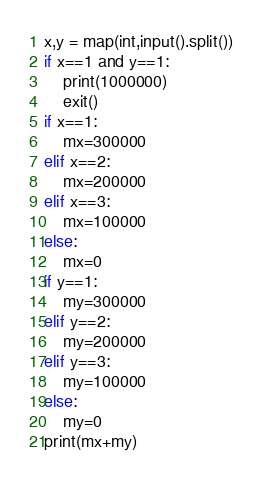<code> <loc_0><loc_0><loc_500><loc_500><_Python_>x,y = map(int,input().split())
if x==1 and y==1:
    print(1000000)
    exit()
if x==1:
    mx=300000
elif x==2:    
    mx=200000
elif x==3:    
    mx=100000    
else:
    mx=0
if y==1:
    my=300000
elif y==2:    
    my=200000
elif y==3:    
    my=100000    
else:
    my=0
print(mx+my)</code> 